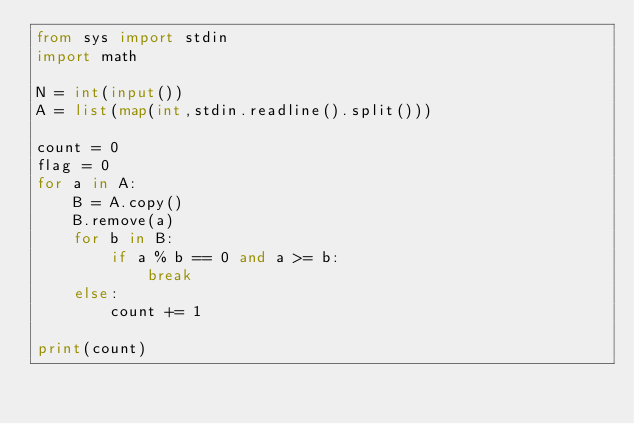<code> <loc_0><loc_0><loc_500><loc_500><_Python_>from sys import stdin
import math

N = int(input())
A = list(map(int,stdin.readline().split()))

count = 0
flag = 0
for a in A:
    B = A.copy()
    B.remove(a)
    for b in B:
        if a % b == 0 and a >= b:
            break
    else:
        count += 1

print(count)
</code> 